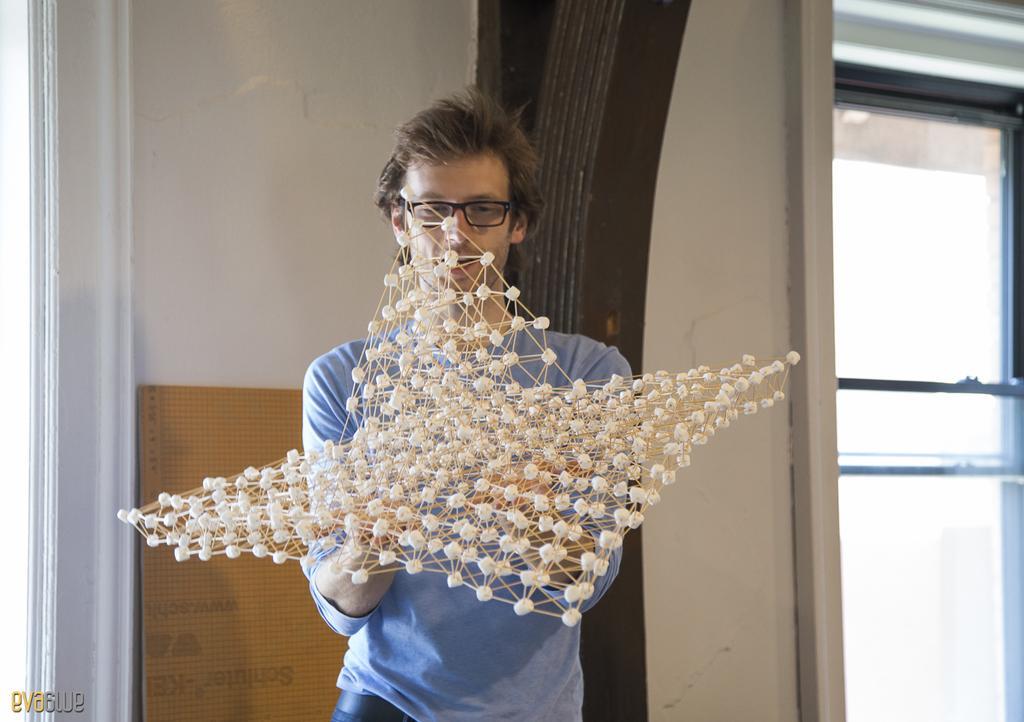In one or two sentences, can you explain what this image depicts? In this image I can see a person holding something and wearing blue t-shirt. Back I can see a window,brown board and wall. 